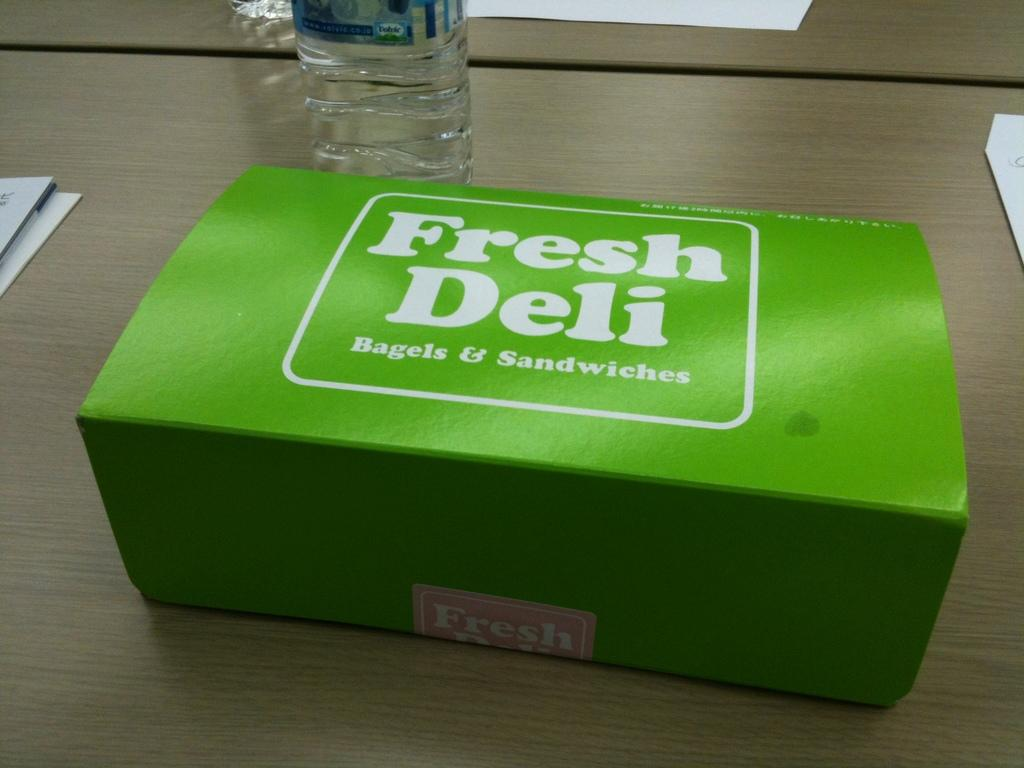<image>
Present a compact description of the photo's key features. A box of food from Fresh Deli Bagels & Sandwiches near a water bottle on a desk. 